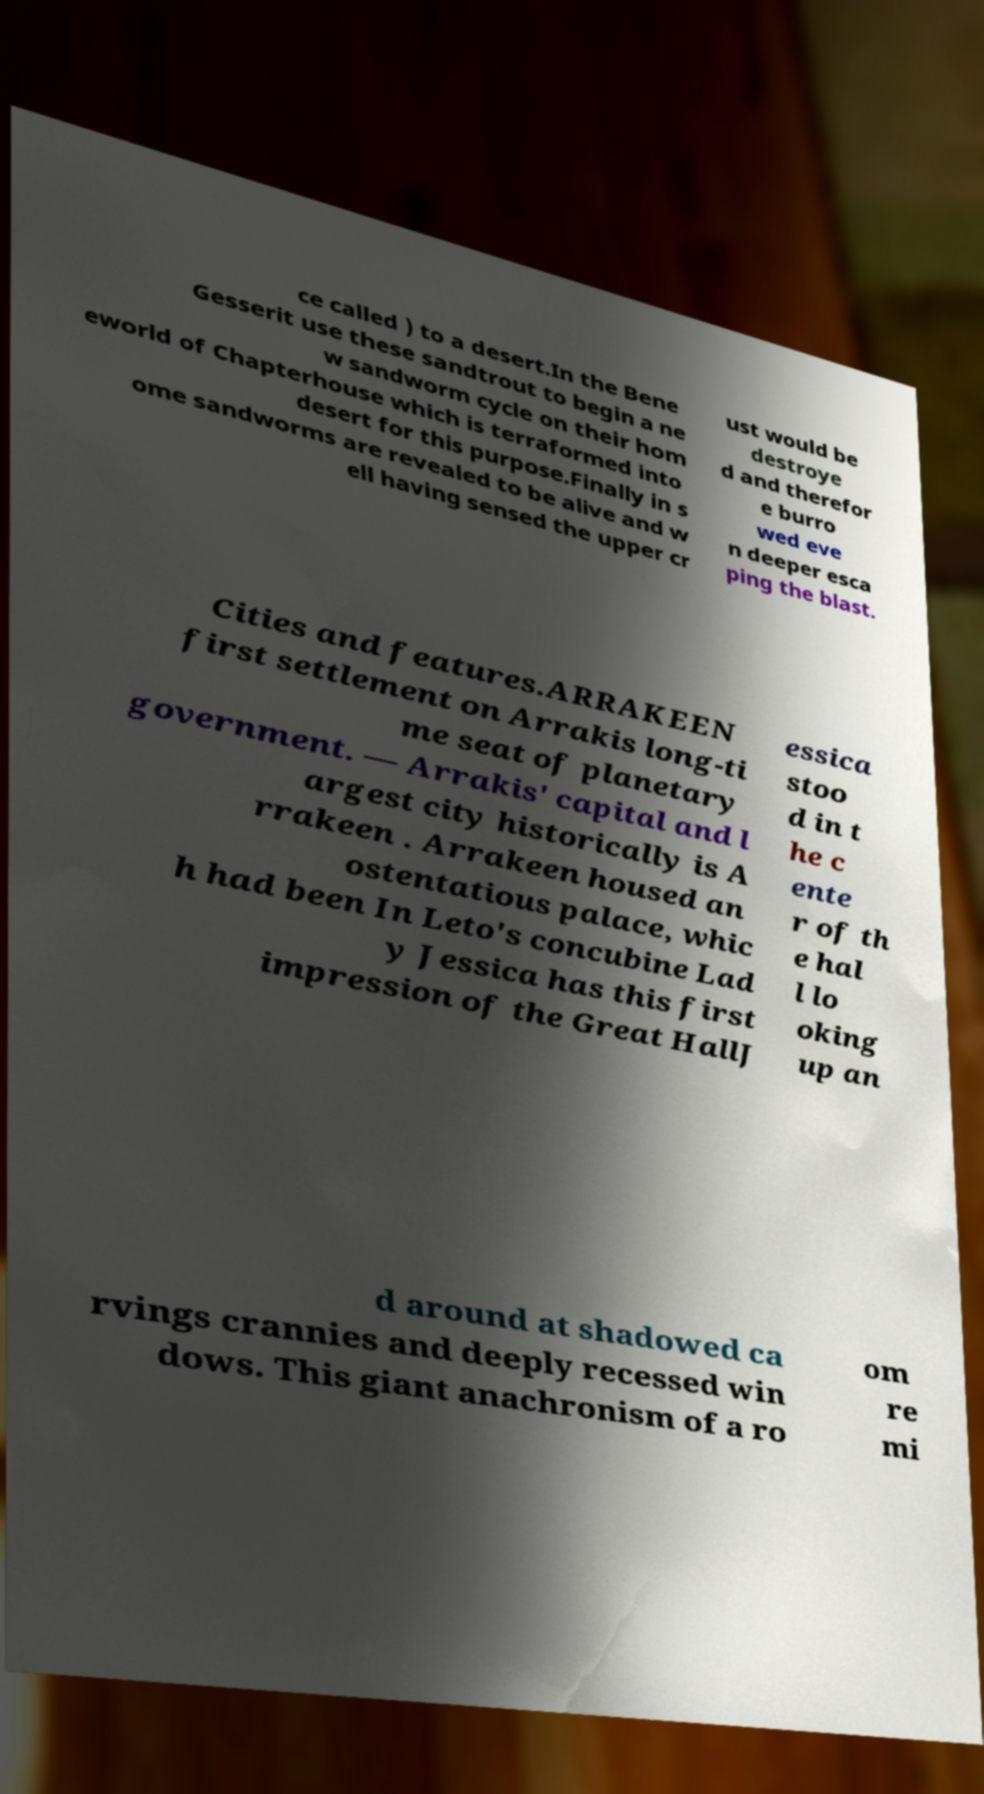Please read and relay the text visible in this image. What does it say? ce called ) to a desert.In the Bene Gesserit use these sandtrout to begin a ne w sandworm cycle on their hom eworld of Chapterhouse which is terraformed into desert for this purpose.Finally in s ome sandworms are revealed to be alive and w ell having sensed the upper cr ust would be destroye d and therefor e burro wed eve n deeper esca ping the blast. Cities and features.ARRAKEEN first settlement on Arrakis long-ti me seat of planetary government. — Arrakis' capital and l argest city historically is A rrakeen . Arrakeen housed an ostentatious palace, whic h had been In Leto's concubine Lad y Jessica has this first impression of the Great HallJ essica stoo d in t he c ente r of th e hal l lo oking up an d around at shadowed ca rvings crannies and deeply recessed win dows. This giant anachronism of a ro om re mi 